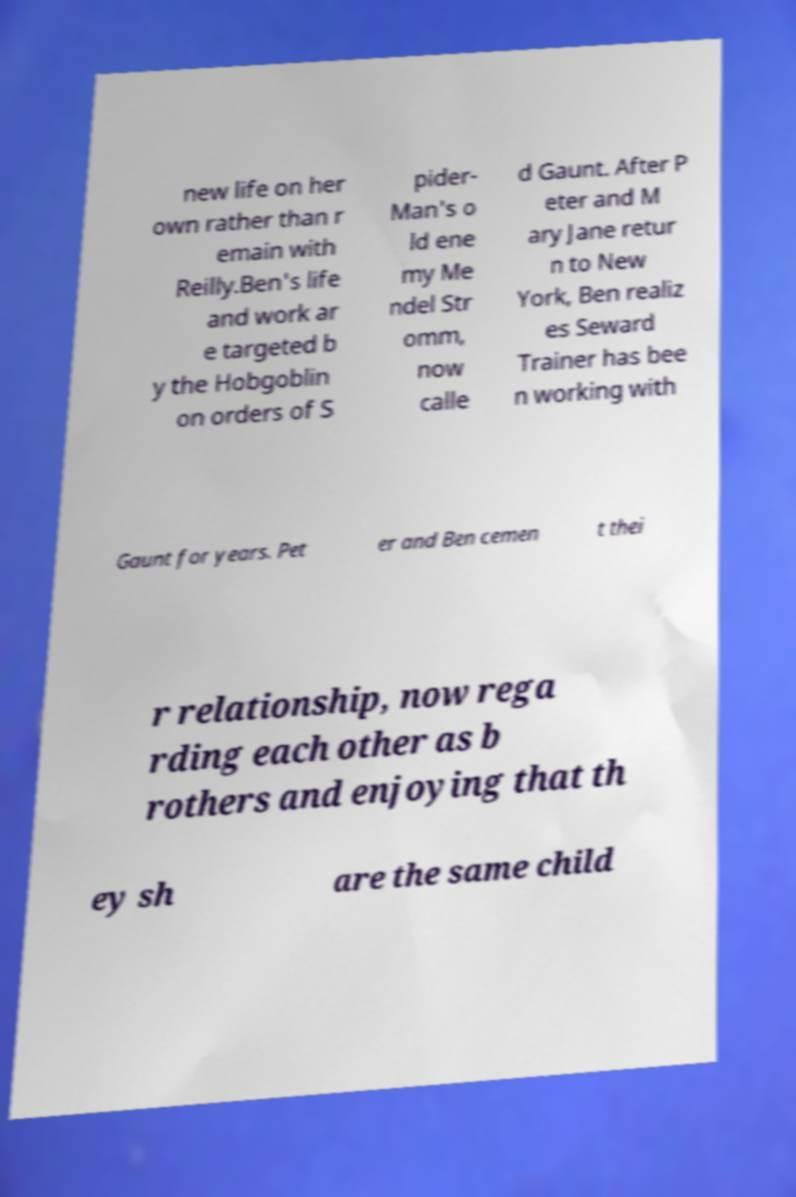Can you accurately transcribe the text from the provided image for me? new life on her own rather than r emain with Reilly.Ben's life and work ar e targeted b y the Hobgoblin on orders of S pider- Man's o ld ene my Me ndel Str omm, now calle d Gaunt. After P eter and M ary Jane retur n to New York, Ben realiz es Seward Trainer has bee n working with Gaunt for years. Pet er and Ben cemen t thei r relationship, now rega rding each other as b rothers and enjoying that th ey sh are the same child 